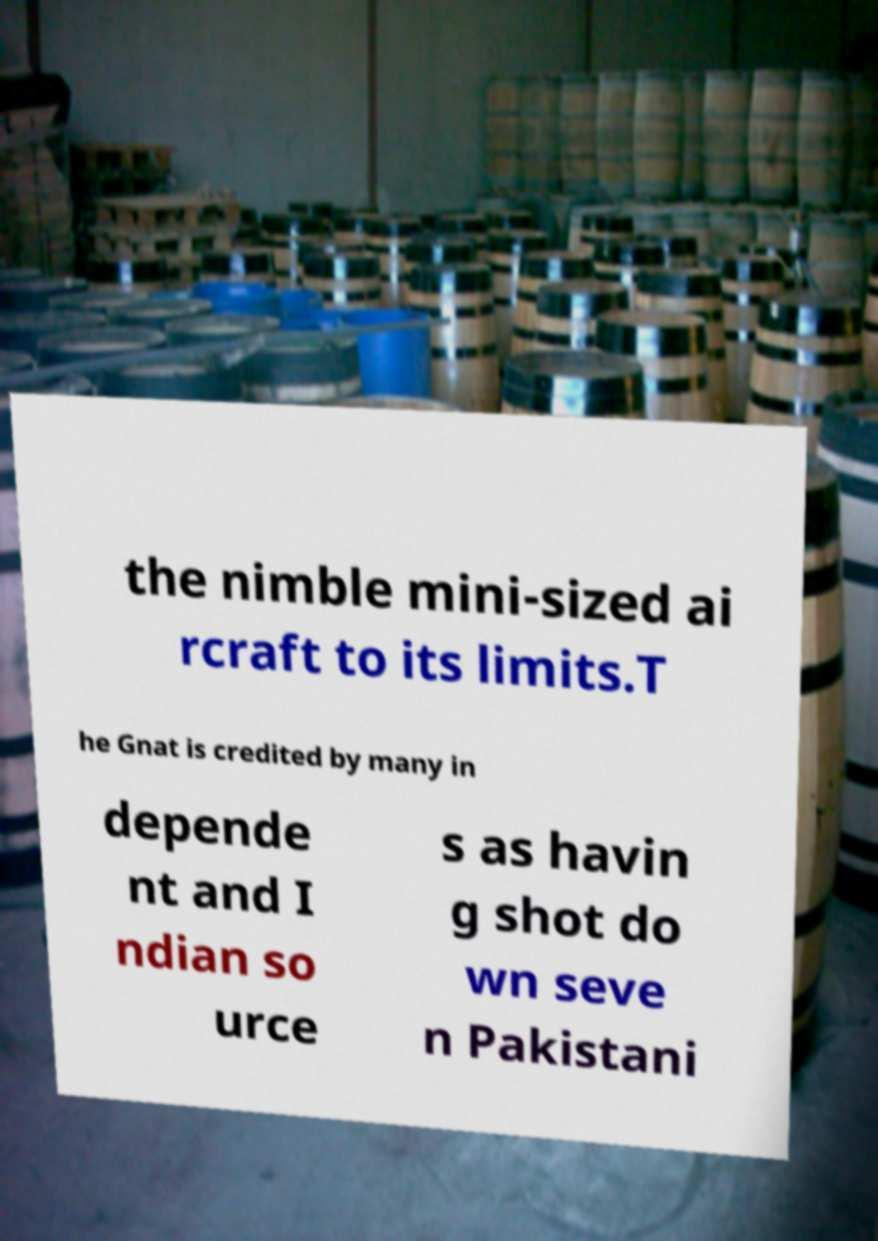For documentation purposes, I need the text within this image transcribed. Could you provide that? the nimble mini-sized ai rcraft to its limits.T he Gnat is credited by many in depende nt and I ndian so urce s as havin g shot do wn seve n Pakistani 